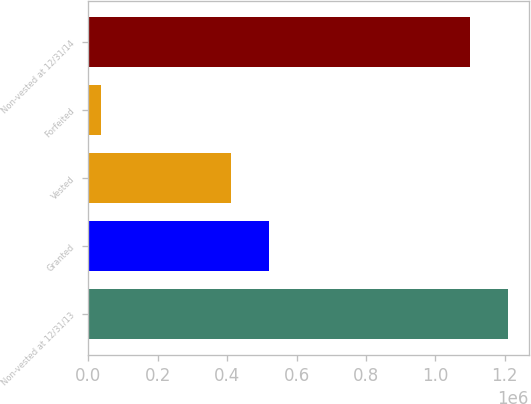Convert chart. <chart><loc_0><loc_0><loc_500><loc_500><bar_chart><fcel>Non-vested at 12/31/13<fcel>Granted<fcel>Vested<fcel>Forfeited<fcel>Non-vested at 12/31/14<nl><fcel>1.20901e+06<fcel>520104<fcel>411704<fcel>37597<fcel>1.10061e+06<nl></chart> 